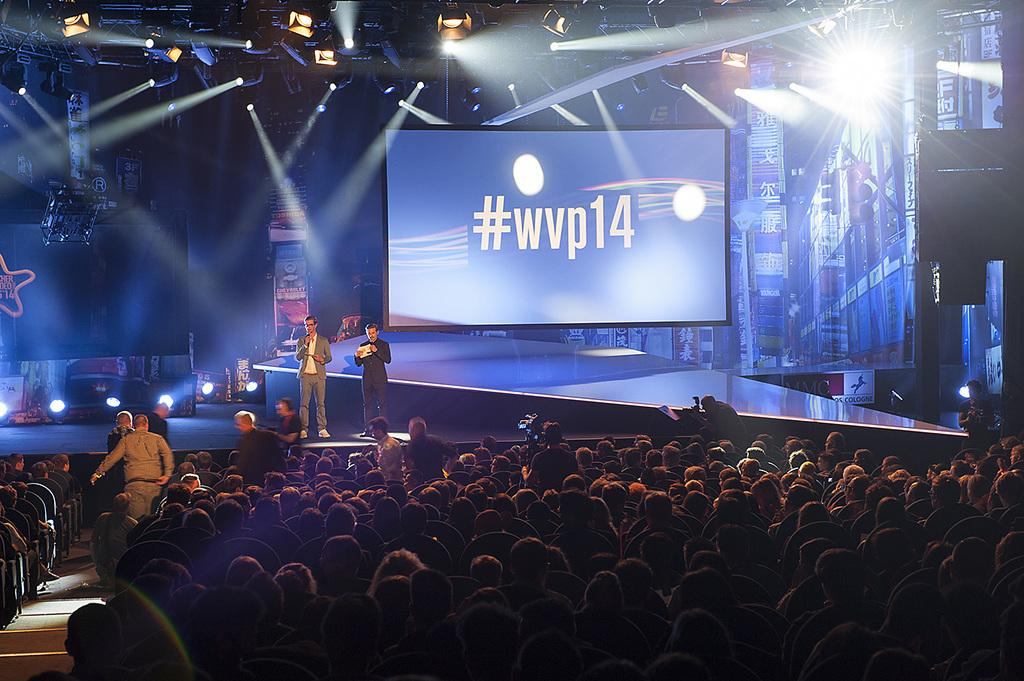Provide a one-sentence caption for the provided image. A large display on a stage with the hashtag #wvp14 on a blue background. 